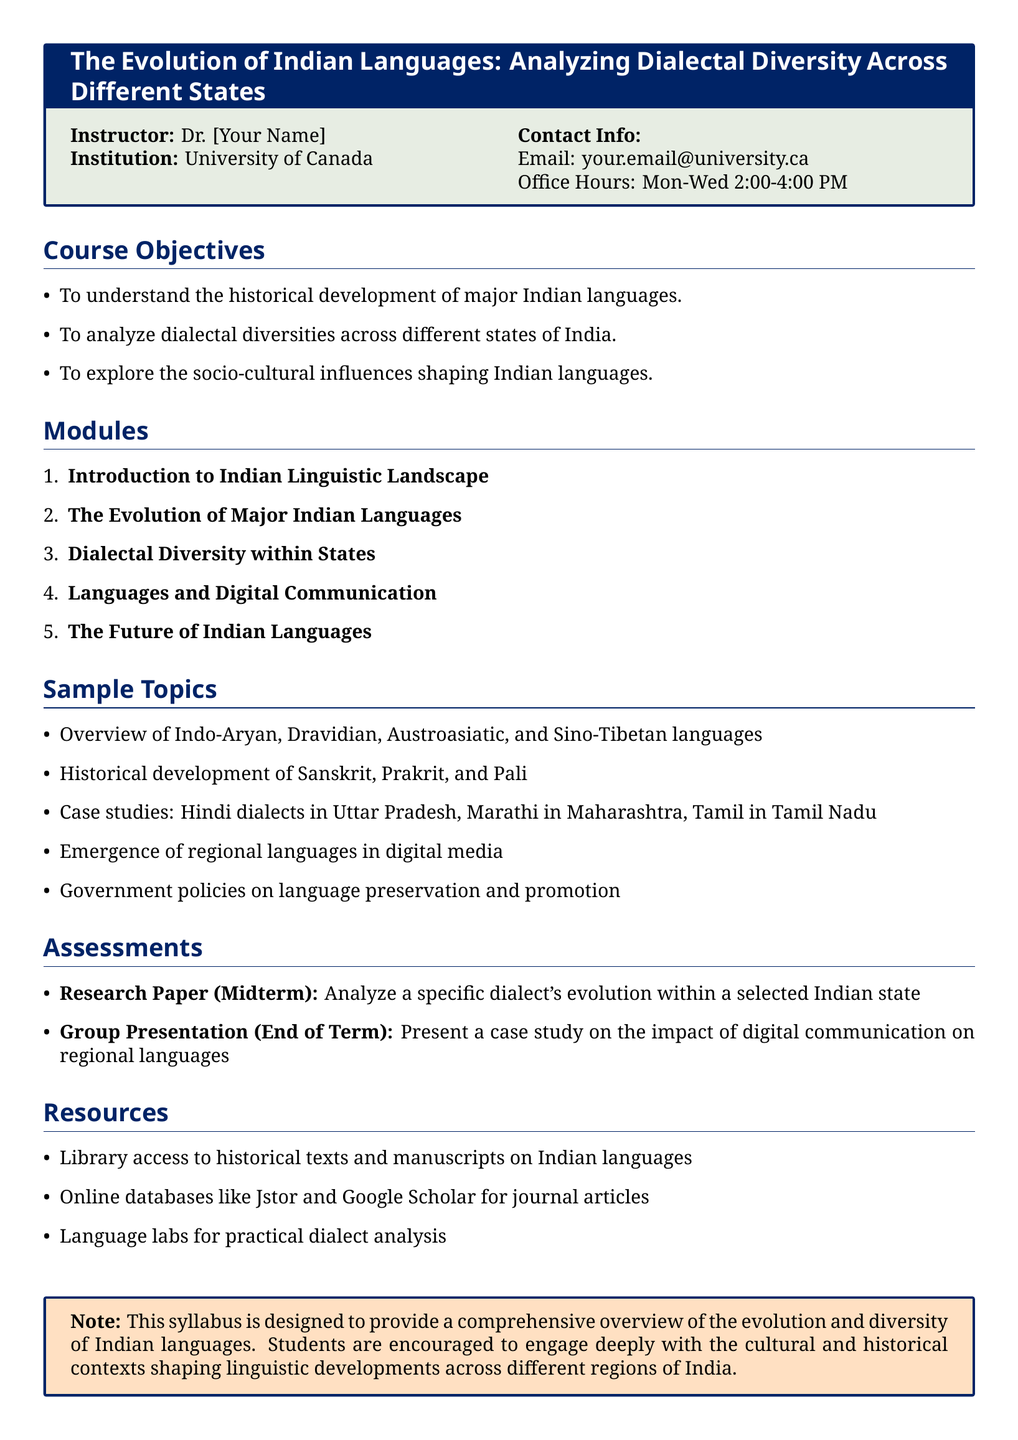What is the name of the instructor? The instructor's name is indicated as Dr. [Your Name].
Answer: Dr. [Your Name] Which university is offering this course? The course is offered by the University of Canada.
Answer: University of Canada How many modules are in the syllabus? The document lists five modules under the course structure.
Answer: 5 What is one of the specific dialects studied in the course? The document mentions Hindi dialects as a specific dialect studied.
Answer: Hindi dialects What type of assessment is a research paper? The document states that the research paper is a midterm assessment.
Answer: Midterm What is the main focus of the "Dialectal Diversity within States" module? The module focuses on the variations in dialects across different Indian states.
Answer: Dialectal diversity Which digital communication aspect is included in the sample topics? The syllabus addresses the emergence of regional languages in digital media.
Answer: Regional languages in digital media What is one resource mentioned for language analysis? The document refers to language labs for practical dialect analysis.
Answer: Language labs What is the overall aim of the course as described in the syllabus? The course aims to provide a comprehensive overview of the evolution and diversity of Indian languages.
Answer: Comprehensive overview 